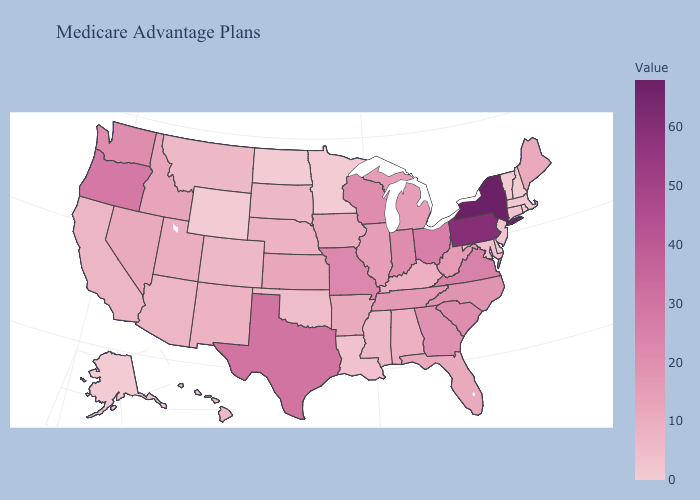Does the map have missing data?
Give a very brief answer. No. Among the states that border Montana , does Wyoming have the highest value?
Give a very brief answer. No. Among the states that border New Jersey , which have the lowest value?
Quick response, please. Delaware. Does Minnesota have a higher value than Idaho?
Give a very brief answer. No. 